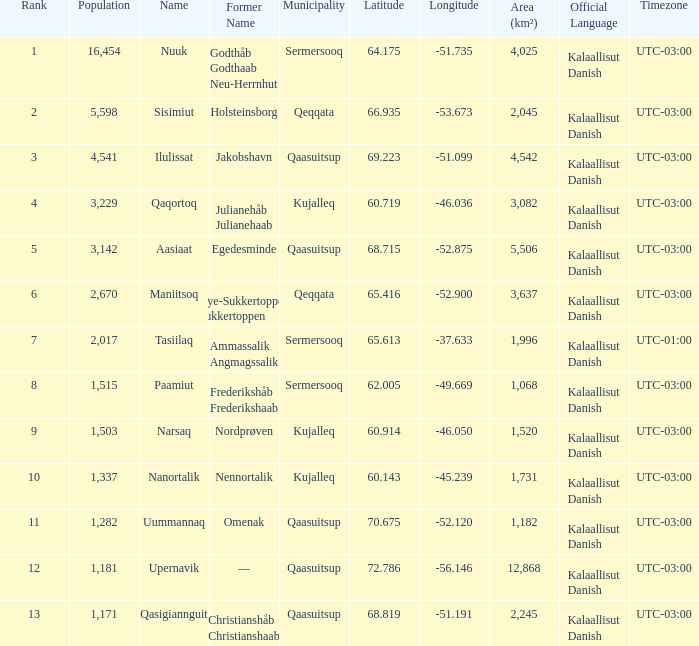What is the population for Rank 11? 1282.0. 